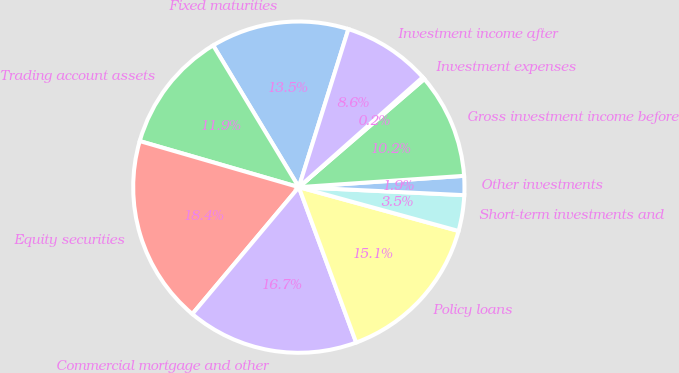Convert chart. <chart><loc_0><loc_0><loc_500><loc_500><pie_chart><fcel>Fixed maturities<fcel>Trading account assets<fcel>Equity securities<fcel>Commercial mortgage and other<fcel>Policy loans<fcel>Short-term investments and<fcel>Other investments<fcel>Gross investment income before<fcel>Investment expenses<fcel>Investment income after<nl><fcel>13.49%<fcel>11.86%<fcel>18.37%<fcel>16.74%<fcel>15.11%<fcel>3.49%<fcel>1.86%<fcel>10.23%<fcel>0.23%<fcel>8.61%<nl></chart> 